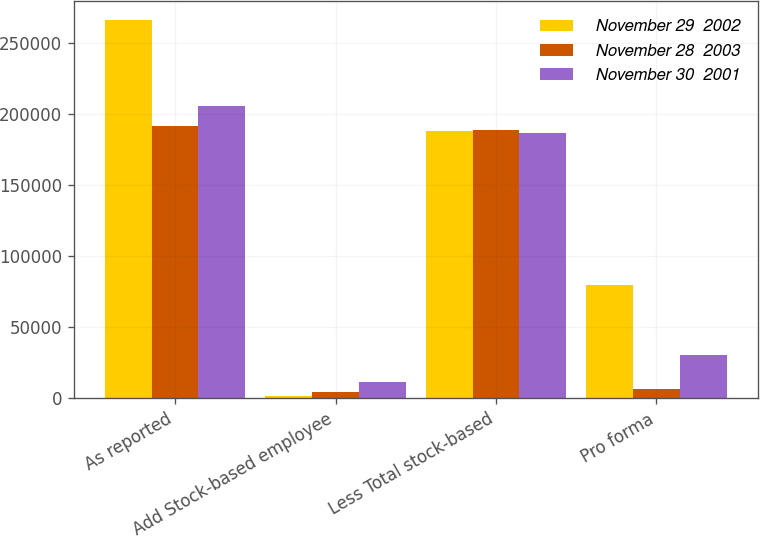Convert chart. <chart><loc_0><loc_0><loc_500><loc_500><stacked_bar_chart><ecel><fcel>As reported<fcel>Add Stock-based employee<fcel>Less Total stock-based<fcel>Pro forma<nl><fcel>November 29  2002<fcel>266344<fcel>1837<fcel>188427<fcel>79754<nl><fcel>November 28  2003<fcel>191399<fcel>4411<fcel>189164<fcel>6646<nl><fcel>November 30  2001<fcel>205644<fcel>11697<fcel>187116<fcel>30225<nl></chart> 